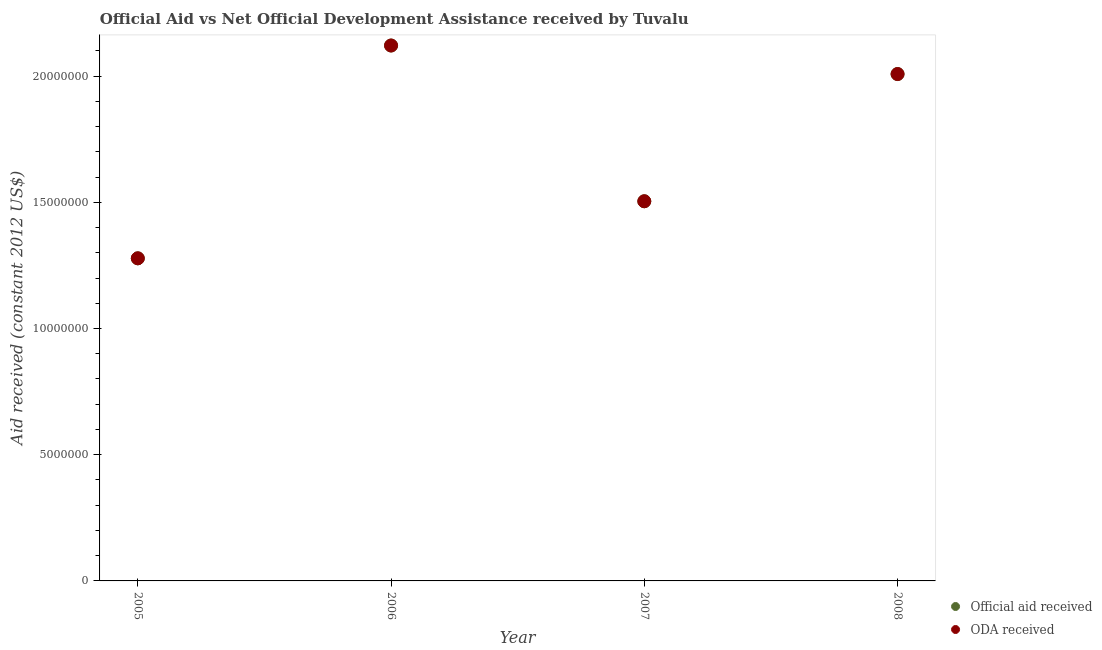How many different coloured dotlines are there?
Make the answer very short. 2. What is the oda received in 2006?
Your answer should be compact. 2.12e+07. Across all years, what is the maximum oda received?
Provide a short and direct response. 2.12e+07. Across all years, what is the minimum official aid received?
Offer a very short reply. 1.28e+07. In which year was the official aid received minimum?
Your answer should be compact. 2005. What is the total oda received in the graph?
Give a very brief answer. 6.91e+07. What is the difference between the oda received in 2006 and that in 2008?
Offer a terse response. 1.13e+06. What is the difference between the official aid received in 2007 and the oda received in 2005?
Offer a terse response. 2.26e+06. What is the average official aid received per year?
Your answer should be compact. 1.73e+07. In how many years, is the oda received greater than 6000000 US$?
Provide a succinct answer. 4. What is the ratio of the oda received in 2006 to that in 2008?
Offer a very short reply. 1.06. Is the difference between the official aid received in 2006 and 2008 greater than the difference between the oda received in 2006 and 2008?
Provide a short and direct response. No. What is the difference between the highest and the second highest official aid received?
Ensure brevity in your answer.  1.13e+06. What is the difference between the highest and the lowest oda received?
Your response must be concise. 8.43e+06. In how many years, is the oda received greater than the average oda received taken over all years?
Offer a terse response. 2. Is the sum of the official aid received in 2006 and 2008 greater than the maximum oda received across all years?
Give a very brief answer. Yes. Does the official aid received monotonically increase over the years?
Your response must be concise. No. Is the oda received strictly greater than the official aid received over the years?
Offer a very short reply. No. Is the oda received strictly less than the official aid received over the years?
Provide a short and direct response. No. How many years are there in the graph?
Ensure brevity in your answer.  4. What is the difference between two consecutive major ticks on the Y-axis?
Provide a succinct answer. 5.00e+06. Where does the legend appear in the graph?
Give a very brief answer. Bottom right. What is the title of the graph?
Your answer should be very brief. Official Aid vs Net Official Development Assistance received by Tuvalu . What is the label or title of the X-axis?
Provide a short and direct response. Year. What is the label or title of the Y-axis?
Ensure brevity in your answer.  Aid received (constant 2012 US$). What is the Aid received (constant 2012 US$) in Official aid received in 2005?
Your answer should be compact. 1.28e+07. What is the Aid received (constant 2012 US$) in ODA received in 2005?
Make the answer very short. 1.28e+07. What is the Aid received (constant 2012 US$) of Official aid received in 2006?
Keep it short and to the point. 2.12e+07. What is the Aid received (constant 2012 US$) of ODA received in 2006?
Offer a terse response. 2.12e+07. What is the Aid received (constant 2012 US$) of Official aid received in 2007?
Keep it short and to the point. 1.50e+07. What is the Aid received (constant 2012 US$) in ODA received in 2007?
Give a very brief answer. 1.50e+07. What is the Aid received (constant 2012 US$) in Official aid received in 2008?
Make the answer very short. 2.01e+07. What is the Aid received (constant 2012 US$) of ODA received in 2008?
Offer a very short reply. 2.01e+07. Across all years, what is the maximum Aid received (constant 2012 US$) of Official aid received?
Give a very brief answer. 2.12e+07. Across all years, what is the maximum Aid received (constant 2012 US$) in ODA received?
Your response must be concise. 2.12e+07. Across all years, what is the minimum Aid received (constant 2012 US$) of Official aid received?
Make the answer very short. 1.28e+07. Across all years, what is the minimum Aid received (constant 2012 US$) of ODA received?
Make the answer very short. 1.28e+07. What is the total Aid received (constant 2012 US$) of Official aid received in the graph?
Give a very brief answer. 6.91e+07. What is the total Aid received (constant 2012 US$) of ODA received in the graph?
Provide a short and direct response. 6.91e+07. What is the difference between the Aid received (constant 2012 US$) of Official aid received in 2005 and that in 2006?
Offer a very short reply. -8.43e+06. What is the difference between the Aid received (constant 2012 US$) in ODA received in 2005 and that in 2006?
Ensure brevity in your answer.  -8.43e+06. What is the difference between the Aid received (constant 2012 US$) in Official aid received in 2005 and that in 2007?
Make the answer very short. -2.26e+06. What is the difference between the Aid received (constant 2012 US$) of ODA received in 2005 and that in 2007?
Provide a short and direct response. -2.26e+06. What is the difference between the Aid received (constant 2012 US$) in Official aid received in 2005 and that in 2008?
Make the answer very short. -7.30e+06. What is the difference between the Aid received (constant 2012 US$) of ODA received in 2005 and that in 2008?
Give a very brief answer. -7.30e+06. What is the difference between the Aid received (constant 2012 US$) of Official aid received in 2006 and that in 2007?
Give a very brief answer. 6.17e+06. What is the difference between the Aid received (constant 2012 US$) of ODA received in 2006 and that in 2007?
Ensure brevity in your answer.  6.17e+06. What is the difference between the Aid received (constant 2012 US$) in Official aid received in 2006 and that in 2008?
Offer a very short reply. 1.13e+06. What is the difference between the Aid received (constant 2012 US$) in ODA received in 2006 and that in 2008?
Offer a terse response. 1.13e+06. What is the difference between the Aid received (constant 2012 US$) of Official aid received in 2007 and that in 2008?
Provide a succinct answer. -5.04e+06. What is the difference between the Aid received (constant 2012 US$) in ODA received in 2007 and that in 2008?
Give a very brief answer. -5.04e+06. What is the difference between the Aid received (constant 2012 US$) of Official aid received in 2005 and the Aid received (constant 2012 US$) of ODA received in 2006?
Keep it short and to the point. -8.43e+06. What is the difference between the Aid received (constant 2012 US$) in Official aid received in 2005 and the Aid received (constant 2012 US$) in ODA received in 2007?
Your response must be concise. -2.26e+06. What is the difference between the Aid received (constant 2012 US$) in Official aid received in 2005 and the Aid received (constant 2012 US$) in ODA received in 2008?
Offer a very short reply. -7.30e+06. What is the difference between the Aid received (constant 2012 US$) in Official aid received in 2006 and the Aid received (constant 2012 US$) in ODA received in 2007?
Provide a short and direct response. 6.17e+06. What is the difference between the Aid received (constant 2012 US$) of Official aid received in 2006 and the Aid received (constant 2012 US$) of ODA received in 2008?
Give a very brief answer. 1.13e+06. What is the difference between the Aid received (constant 2012 US$) of Official aid received in 2007 and the Aid received (constant 2012 US$) of ODA received in 2008?
Provide a short and direct response. -5.04e+06. What is the average Aid received (constant 2012 US$) of Official aid received per year?
Provide a succinct answer. 1.73e+07. What is the average Aid received (constant 2012 US$) of ODA received per year?
Keep it short and to the point. 1.73e+07. In the year 2006, what is the difference between the Aid received (constant 2012 US$) in Official aid received and Aid received (constant 2012 US$) in ODA received?
Offer a terse response. 0. In the year 2007, what is the difference between the Aid received (constant 2012 US$) of Official aid received and Aid received (constant 2012 US$) of ODA received?
Keep it short and to the point. 0. In the year 2008, what is the difference between the Aid received (constant 2012 US$) of Official aid received and Aid received (constant 2012 US$) of ODA received?
Offer a terse response. 0. What is the ratio of the Aid received (constant 2012 US$) in Official aid received in 2005 to that in 2006?
Your answer should be very brief. 0.6. What is the ratio of the Aid received (constant 2012 US$) of ODA received in 2005 to that in 2006?
Give a very brief answer. 0.6. What is the ratio of the Aid received (constant 2012 US$) of Official aid received in 2005 to that in 2007?
Keep it short and to the point. 0.85. What is the ratio of the Aid received (constant 2012 US$) of ODA received in 2005 to that in 2007?
Offer a very short reply. 0.85. What is the ratio of the Aid received (constant 2012 US$) in Official aid received in 2005 to that in 2008?
Provide a short and direct response. 0.64. What is the ratio of the Aid received (constant 2012 US$) in ODA received in 2005 to that in 2008?
Provide a succinct answer. 0.64. What is the ratio of the Aid received (constant 2012 US$) in Official aid received in 2006 to that in 2007?
Your response must be concise. 1.41. What is the ratio of the Aid received (constant 2012 US$) in ODA received in 2006 to that in 2007?
Ensure brevity in your answer.  1.41. What is the ratio of the Aid received (constant 2012 US$) in Official aid received in 2006 to that in 2008?
Your answer should be compact. 1.06. What is the ratio of the Aid received (constant 2012 US$) in ODA received in 2006 to that in 2008?
Provide a succinct answer. 1.06. What is the ratio of the Aid received (constant 2012 US$) in Official aid received in 2007 to that in 2008?
Make the answer very short. 0.75. What is the ratio of the Aid received (constant 2012 US$) in ODA received in 2007 to that in 2008?
Provide a succinct answer. 0.75. What is the difference between the highest and the second highest Aid received (constant 2012 US$) in Official aid received?
Provide a succinct answer. 1.13e+06. What is the difference between the highest and the second highest Aid received (constant 2012 US$) in ODA received?
Your response must be concise. 1.13e+06. What is the difference between the highest and the lowest Aid received (constant 2012 US$) in Official aid received?
Give a very brief answer. 8.43e+06. What is the difference between the highest and the lowest Aid received (constant 2012 US$) of ODA received?
Your answer should be very brief. 8.43e+06. 